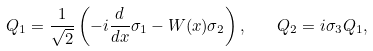<formula> <loc_0><loc_0><loc_500><loc_500>Q _ { 1 } = \frac { 1 } { \sqrt { 2 } } \left ( - i \frac { d } { d x } \sigma _ { 1 } - W ( x ) \sigma _ { 2 } \right ) , \quad Q _ { 2 } = i \sigma _ { 3 } Q _ { 1 } ,</formula> 